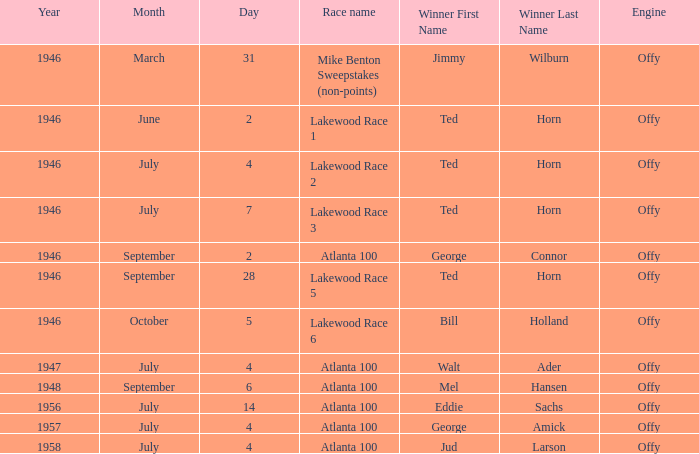Parse the table in full. {'header': ['Year', 'Month', 'Day', 'Race name', 'Winner First Name', 'Winner Last Name', 'Engine'], 'rows': [['1946', 'March', '31', 'Mike Benton Sweepstakes (non-points)', 'Jimmy', 'Wilburn', 'Offy'], ['1946', 'June', '2', 'Lakewood Race 1', 'Ted', 'Horn', 'Offy'], ['1946', 'July', '4', 'Lakewood Race 2', 'Ted', 'Horn', 'Offy'], ['1946', 'July', '7', 'Lakewood Race 3', 'Ted', 'Horn', 'Offy'], ['1946', 'September', '2', 'Atlanta 100', 'George', 'Connor', 'Offy'], ['1946', 'September', '28', 'Lakewood Race 5', 'Ted', 'Horn', 'Offy'], ['1946', 'October', '5', 'Lakewood Race 6', 'Bill', 'Holland', 'Offy'], ['1947', 'July', '4', 'Atlanta 100', 'Walt', 'Ader', 'Offy'], ['1948', 'September', '6', 'Atlanta 100', 'Mel', 'Hansen', 'Offy'], ['1956', 'July', '14', 'Atlanta 100', 'Eddie', 'Sachs', 'Offy'], ['1957', 'July', '4', 'Atlanta 100', 'George', 'Amick', 'Offy'], ['1958', 'July', '4', 'Atlanta 100', 'Jud', 'Larson', 'Offy']]} What date did Ted Horn win Lakewood Race 2? July 4. 